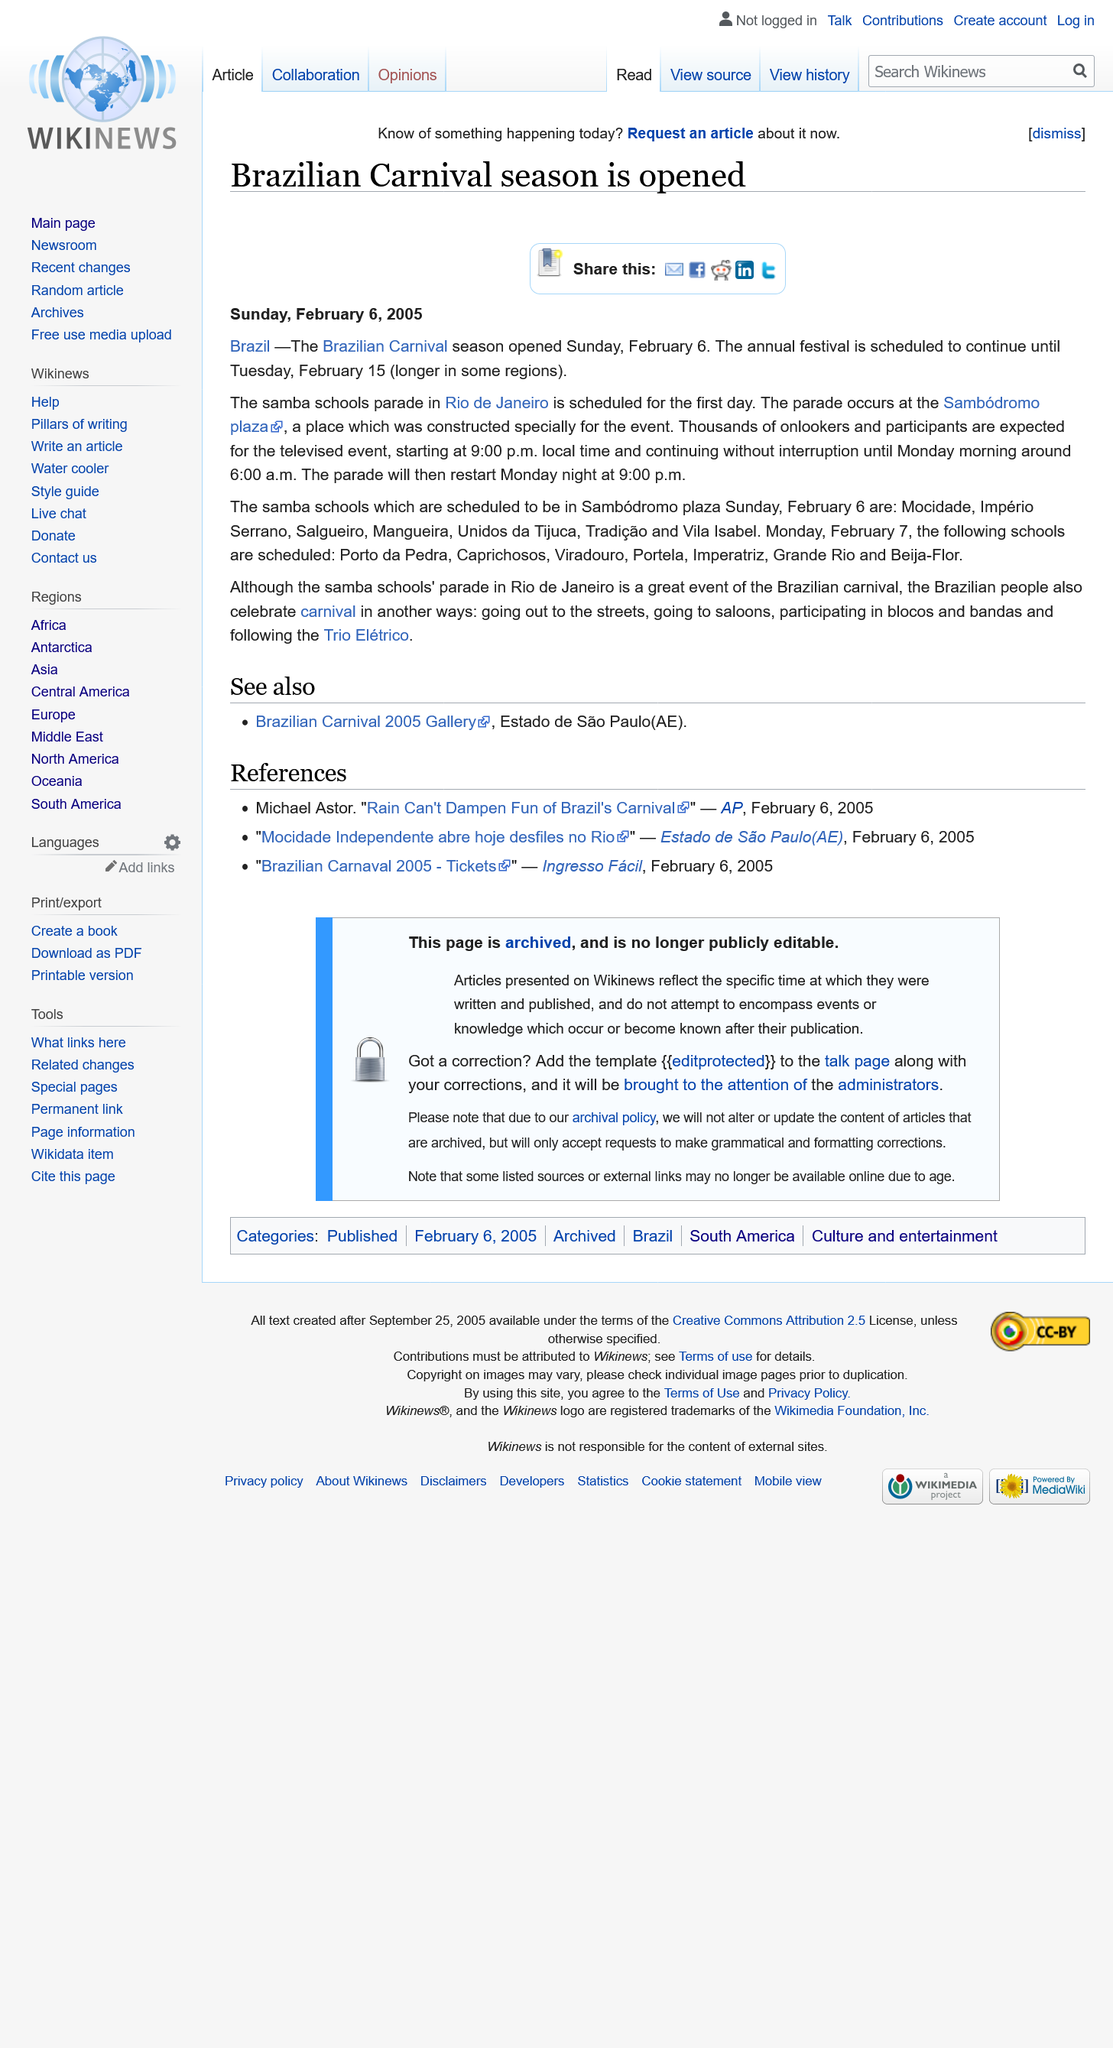Identify some key points in this picture. The Sambodromo plaza is the location where the parade takes place. On Monday, February 7, the following schools have been scheduled: Porto de Pedra, Caprichosos, Viradouro, Po0rtela, Imperaltriz, Grande Rio and Beija-Flor. The Brazilian Carnival season officially opened on Sunday, February 6. 